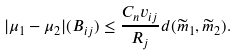<formula> <loc_0><loc_0><loc_500><loc_500>| \mu _ { 1 } - \mu _ { 2 } | ( B _ { i j } ) \leq \frac { C _ { n } v _ { i j } } { R _ { j } } d ( \widetilde { m } _ { 1 } , \widetilde { m } _ { 2 } ) .</formula> 